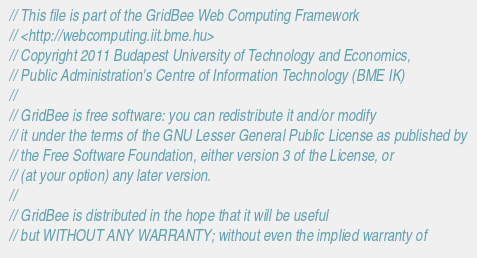Convert code to text. <code><loc_0><loc_0><loc_500><loc_500><_Haxe_>// This file is part of the GridBee Web Computing Framework
// <http://webcomputing.iit.bme.hu>
// Copyright 2011 Budapest University of Technology and Economics,
// Public Administration's Centre of Information Technology (BME IK)
//
// GridBee is free software: you can redistribute it and/or modify
// it under the terms of the GNU Lesser General Public License as published by
// the Free Software Foundation, either version 3 of the License, or
// (at your option) any later version.
//
// GridBee is distributed in the hope that it will be useful
// but WITHOUT ANY WARRANTY; without even the implied warranty of</code> 